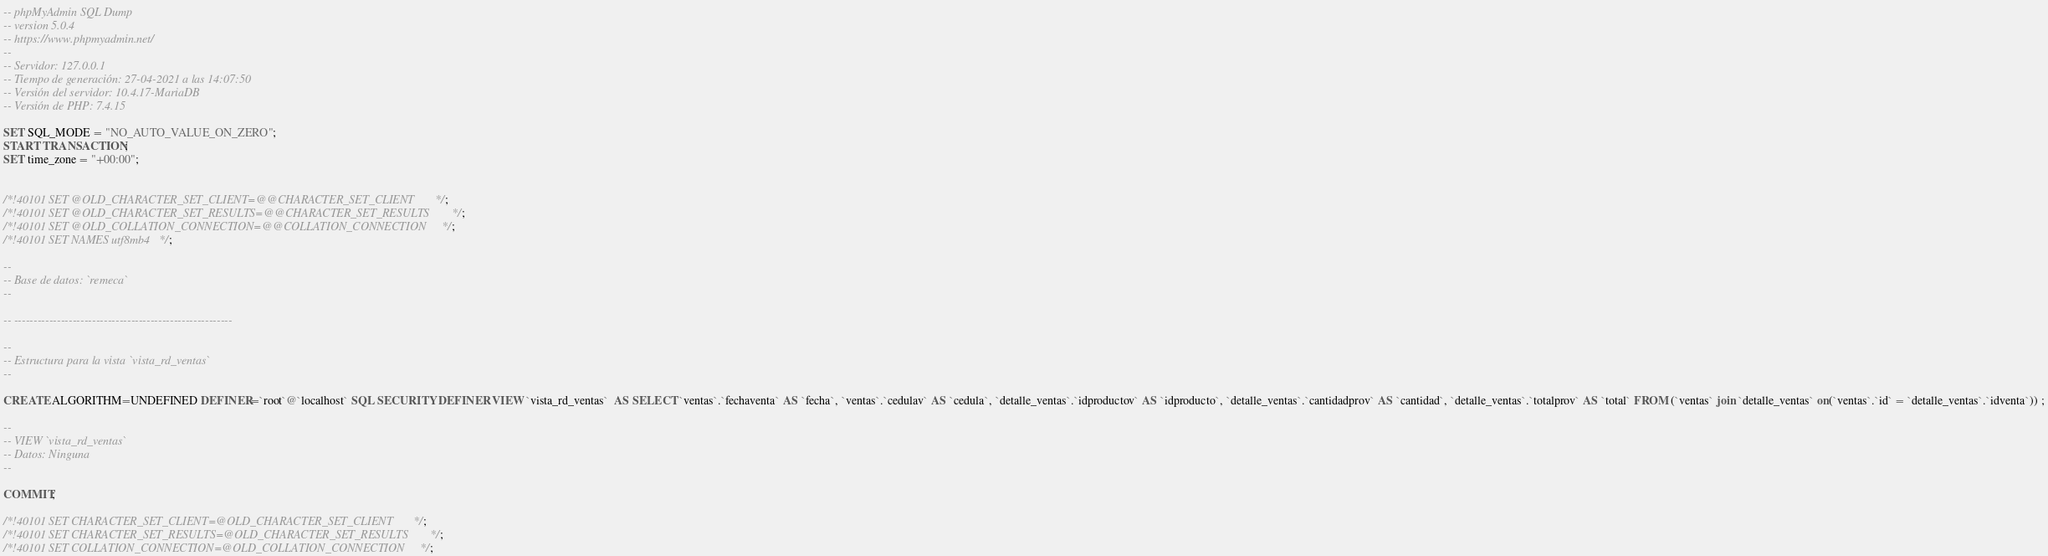Convert code to text. <code><loc_0><loc_0><loc_500><loc_500><_SQL_>-- phpMyAdmin SQL Dump
-- version 5.0.4
-- https://www.phpmyadmin.net/
--
-- Servidor: 127.0.0.1
-- Tiempo de generación: 27-04-2021 a las 14:07:50
-- Versión del servidor: 10.4.17-MariaDB
-- Versión de PHP: 7.4.15

SET SQL_MODE = "NO_AUTO_VALUE_ON_ZERO";
START TRANSACTION;
SET time_zone = "+00:00";


/*!40101 SET @OLD_CHARACTER_SET_CLIENT=@@CHARACTER_SET_CLIENT */;
/*!40101 SET @OLD_CHARACTER_SET_RESULTS=@@CHARACTER_SET_RESULTS */;
/*!40101 SET @OLD_COLLATION_CONNECTION=@@COLLATION_CONNECTION */;
/*!40101 SET NAMES utf8mb4 */;

--
-- Base de datos: `remeca`
--

-- --------------------------------------------------------

--
-- Estructura para la vista `vista_rd_ventas`
--

CREATE ALGORITHM=UNDEFINED DEFINER=`root`@`localhost` SQL SECURITY DEFINER VIEW `vista_rd_ventas`  AS SELECT `ventas`.`fechaventa` AS `fecha`, `ventas`.`cedulav` AS `cedula`, `detalle_ventas`.`idproductov` AS `idproducto`, `detalle_ventas`.`cantidadprov` AS `cantidad`, `detalle_ventas`.`totalprov` AS `total` FROM (`ventas` join `detalle_ventas` on(`ventas`.`id` = `detalle_ventas`.`idventa`)) ;

--
-- VIEW `vista_rd_ventas`
-- Datos: Ninguna
--

COMMIT;

/*!40101 SET CHARACTER_SET_CLIENT=@OLD_CHARACTER_SET_CLIENT */;
/*!40101 SET CHARACTER_SET_RESULTS=@OLD_CHARACTER_SET_RESULTS */;
/*!40101 SET COLLATION_CONNECTION=@OLD_COLLATION_CONNECTION */;
</code> 